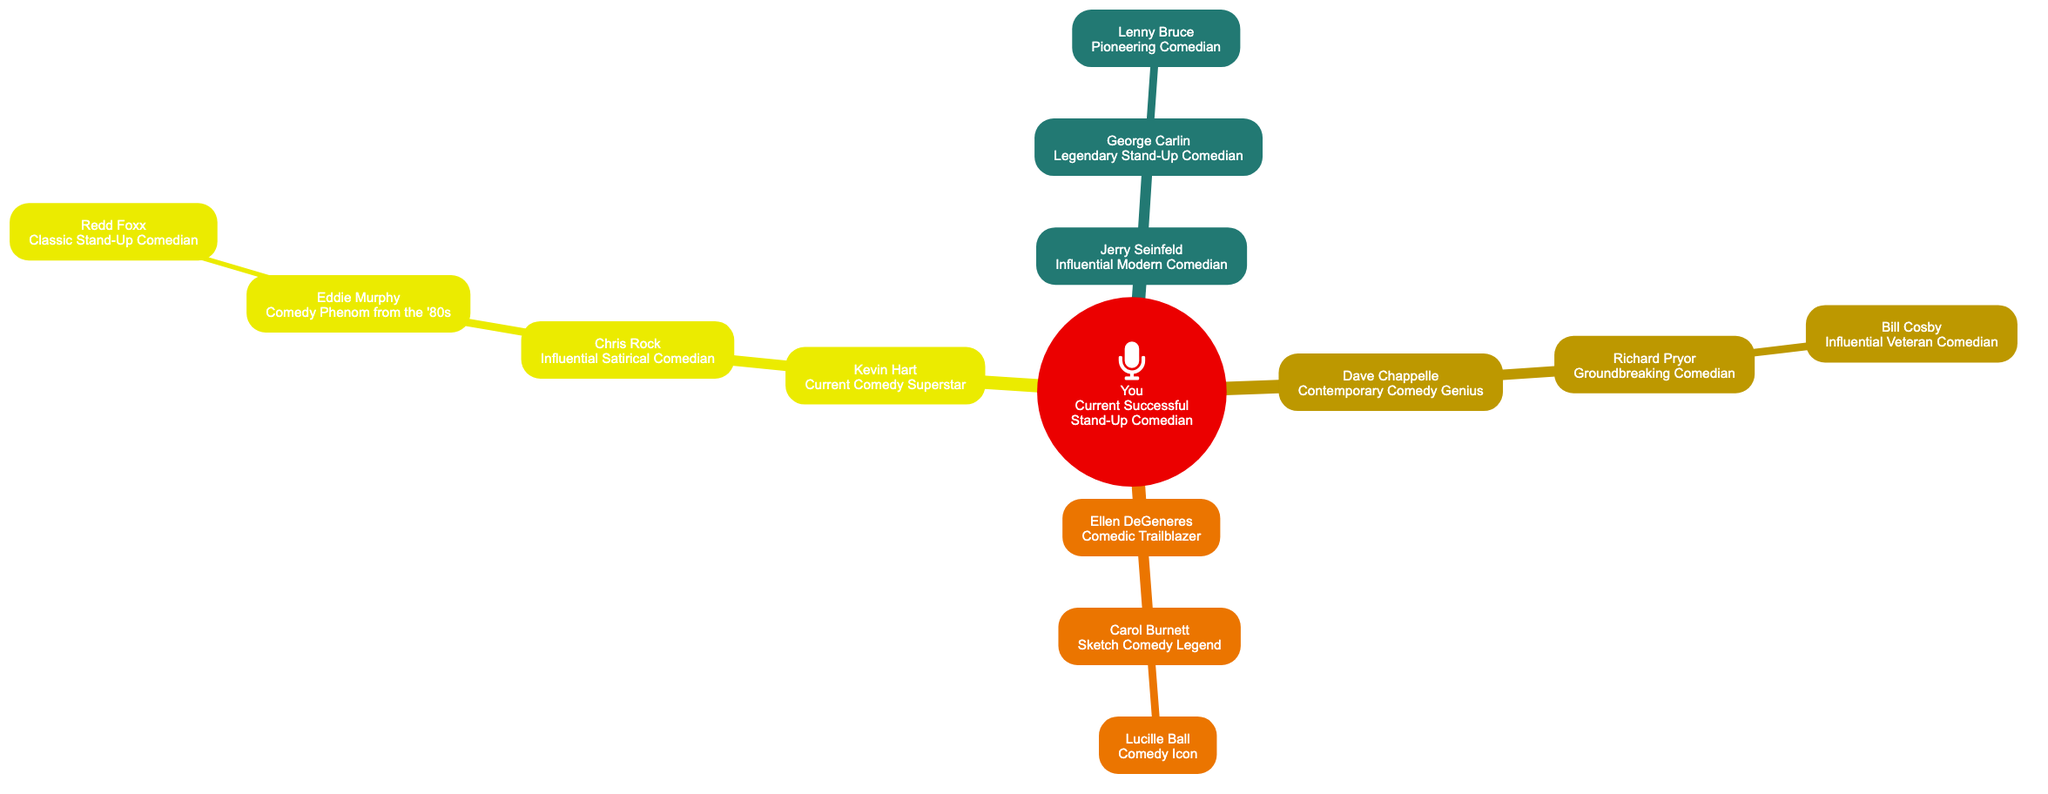What is the title of the root node? The root node represents "You" who is labeled as the "Current Successful Stand-Up Comedian."
Answer: Current Successful Stand-Up Comedian How many children does Jerry Seinfeld have? Jerry Seinfeld has one child in the diagram, which is George Carlin.
Answer: 1 Who is George Carlin's mentor? George Carlin is mentored by Jerry Seinfeld, as indicated by the direct connection between them.
Answer: Jerry Seinfeld What title does Richard Pryor hold? Richard Pryor is labeled as a "Groundbreaking Comedian" in the diagram.
Answer: Groundbreaking Comedian Which comedian is listed as the child of Chris Rock? Chris Rock has one child in the diagram, which is Eddie Murphy.
Answer: Eddie Murphy Who is the most senior comedian in the diagram? Lenny Bruce is noted as the most senior, being the earliest figure in the lineage, connected to George Carlin.
Answer: Lenny Bruce How many total generations are represented in the diagram? The diagram includes four generations: Current Successful Stand-Up Comedian, Influential Comedians, Legendary and Groundbreaking Comedians, and Pioneering Comedians.
Answer: 4 Name the comedic influence directly connected to Kevin Hart. The comedic influence directly connected to Kevin Hart is Chris Rock.
Answer: Chris Rock What is the relationship between Eddid Murphy and Redd Foxx? Eddie Murphy is the child of Chris Rock, whose parent is a direct descendant of Redd Foxx. Therefore, Redd Foxx is a great-grandparent in this lineage.
Answer: Great-grandparent 